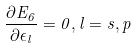Convert formula to latex. <formula><loc_0><loc_0><loc_500><loc_500>\frac { \partial E _ { 6 } } { \partial \epsilon _ { l } } = 0 , l = s , p</formula> 